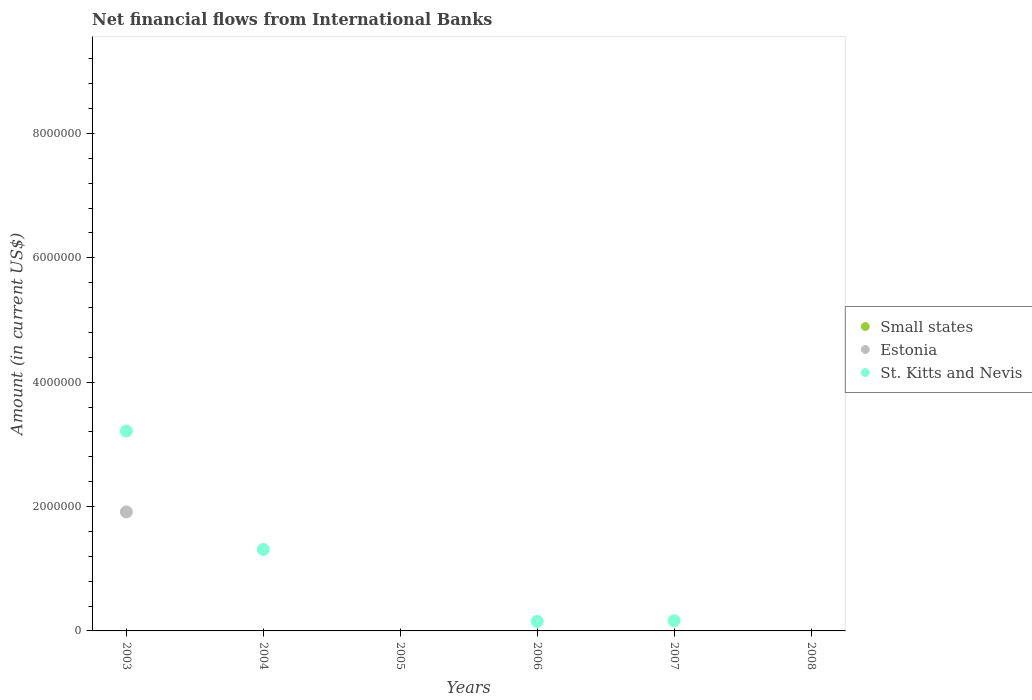Is the number of dotlines equal to the number of legend labels?
Offer a very short reply. No. Across all years, what is the maximum net financial aid flows in St. Kitts and Nevis?
Keep it short and to the point. 3.21e+06. In which year was the net financial aid flows in St. Kitts and Nevis maximum?
Ensure brevity in your answer.  2003. What is the difference between the net financial aid flows in St. Kitts and Nevis in 2003 and that in 2006?
Your answer should be compact. 3.06e+06. What is the difference between the net financial aid flows in St. Kitts and Nevis in 2004 and the net financial aid flows in Estonia in 2003?
Make the answer very short. -6.05e+05. What is the average net financial aid flows in Estonia per year?
Ensure brevity in your answer.  3.19e+05. In how many years, is the net financial aid flows in Estonia greater than 400000 US$?
Offer a very short reply. 1. What is the ratio of the net financial aid flows in St. Kitts and Nevis in 2003 to that in 2004?
Give a very brief answer. 2.46. What is the difference between the highest and the second highest net financial aid flows in St. Kitts and Nevis?
Make the answer very short. 1.90e+06. What is the difference between the highest and the lowest net financial aid flows in St. Kitts and Nevis?
Make the answer very short. 3.21e+06. In how many years, is the net financial aid flows in Small states greater than the average net financial aid flows in Small states taken over all years?
Your answer should be compact. 0. Does the net financial aid flows in St. Kitts and Nevis monotonically increase over the years?
Your response must be concise. No. How many years are there in the graph?
Offer a very short reply. 6. Are the values on the major ticks of Y-axis written in scientific E-notation?
Offer a very short reply. No. Does the graph contain grids?
Offer a very short reply. No. Where does the legend appear in the graph?
Your answer should be very brief. Center right. What is the title of the graph?
Provide a short and direct response. Net financial flows from International Banks. Does "Nicaragua" appear as one of the legend labels in the graph?
Provide a succinct answer. No. What is the Amount (in current US$) of Estonia in 2003?
Your answer should be compact. 1.91e+06. What is the Amount (in current US$) of St. Kitts and Nevis in 2003?
Your answer should be very brief. 3.21e+06. What is the Amount (in current US$) of St. Kitts and Nevis in 2004?
Offer a terse response. 1.31e+06. What is the Amount (in current US$) of Estonia in 2005?
Give a very brief answer. 0. What is the Amount (in current US$) in St. Kitts and Nevis in 2005?
Offer a very short reply. 0. What is the Amount (in current US$) of St. Kitts and Nevis in 2006?
Offer a very short reply. 1.53e+05. What is the Amount (in current US$) of St. Kitts and Nevis in 2007?
Provide a short and direct response. 1.64e+05. What is the Amount (in current US$) of Small states in 2008?
Offer a very short reply. 0. What is the Amount (in current US$) in Estonia in 2008?
Make the answer very short. 0. What is the Amount (in current US$) of St. Kitts and Nevis in 2008?
Offer a terse response. 0. Across all years, what is the maximum Amount (in current US$) of Estonia?
Offer a terse response. 1.91e+06. Across all years, what is the maximum Amount (in current US$) in St. Kitts and Nevis?
Offer a terse response. 3.21e+06. Across all years, what is the minimum Amount (in current US$) of St. Kitts and Nevis?
Offer a very short reply. 0. What is the total Amount (in current US$) of Estonia in the graph?
Provide a short and direct response. 1.91e+06. What is the total Amount (in current US$) of St. Kitts and Nevis in the graph?
Give a very brief answer. 4.84e+06. What is the difference between the Amount (in current US$) of St. Kitts and Nevis in 2003 and that in 2004?
Your answer should be very brief. 1.90e+06. What is the difference between the Amount (in current US$) of St. Kitts and Nevis in 2003 and that in 2006?
Your answer should be very brief. 3.06e+06. What is the difference between the Amount (in current US$) in St. Kitts and Nevis in 2003 and that in 2007?
Make the answer very short. 3.05e+06. What is the difference between the Amount (in current US$) in St. Kitts and Nevis in 2004 and that in 2006?
Make the answer very short. 1.16e+06. What is the difference between the Amount (in current US$) of St. Kitts and Nevis in 2004 and that in 2007?
Ensure brevity in your answer.  1.14e+06. What is the difference between the Amount (in current US$) of St. Kitts and Nevis in 2006 and that in 2007?
Your response must be concise. -1.10e+04. What is the difference between the Amount (in current US$) in Estonia in 2003 and the Amount (in current US$) in St. Kitts and Nevis in 2004?
Ensure brevity in your answer.  6.05e+05. What is the difference between the Amount (in current US$) in Estonia in 2003 and the Amount (in current US$) in St. Kitts and Nevis in 2006?
Your answer should be very brief. 1.76e+06. What is the difference between the Amount (in current US$) in Estonia in 2003 and the Amount (in current US$) in St. Kitts and Nevis in 2007?
Provide a succinct answer. 1.75e+06. What is the average Amount (in current US$) in Small states per year?
Your response must be concise. 0. What is the average Amount (in current US$) in Estonia per year?
Provide a succinct answer. 3.19e+05. What is the average Amount (in current US$) of St. Kitts and Nevis per year?
Your response must be concise. 8.07e+05. In the year 2003, what is the difference between the Amount (in current US$) in Estonia and Amount (in current US$) in St. Kitts and Nevis?
Your response must be concise. -1.30e+06. What is the ratio of the Amount (in current US$) in St. Kitts and Nevis in 2003 to that in 2004?
Keep it short and to the point. 2.46. What is the ratio of the Amount (in current US$) of St. Kitts and Nevis in 2003 to that in 2006?
Your answer should be very brief. 21.01. What is the ratio of the Amount (in current US$) in St. Kitts and Nevis in 2003 to that in 2007?
Offer a very short reply. 19.6. What is the ratio of the Amount (in current US$) of St. Kitts and Nevis in 2004 to that in 2006?
Give a very brief answer. 8.56. What is the ratio of the Amount (in current US$) of St. Kitts and Nevis in 2004 to that in 2007?
Make the answer very short. 7.98. What is the ratio of the Amount (in current US$) of St. Kitts and Nevis in 2006 to that in 2007?
Provide a succinct answer. 0.93. What is the difference between the highest and the second highest Amount (in current US$) of St. Kitts and Nevis?
Keep it short and to the point. 1.90e+06. What is the difference between the highest and the lowest Amount (in current US$) of Estonia?
Give a very brief answer. 1.91e+06. What is the difference between the highest and the lowest Amount (in current US$) in St. Kitts and Nevis?
Make the answer very short. 3.21e+06. 